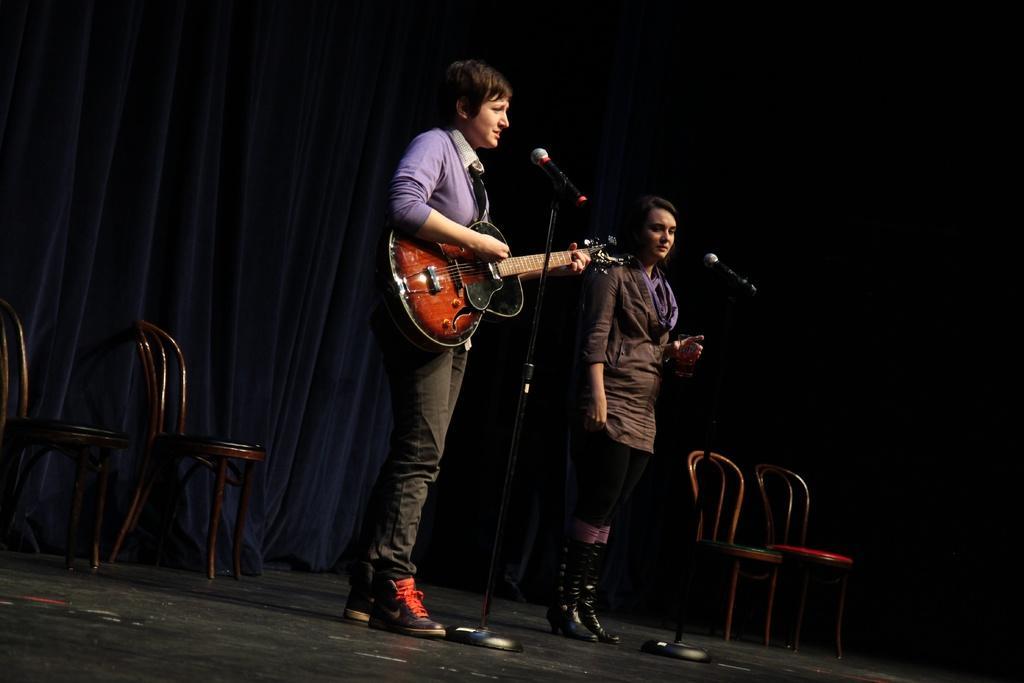Describe this image in one or two sentences. A woman is playing guitar and singing. In front of her a mic stand is there. Another lady wearing brown jacket wearing boots. In front of her mic stand. there are some chairs. in the background there is a curtain. 